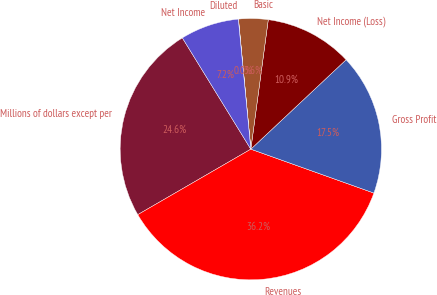Convert chart to OTSL. <chart><loc_0><loc_0><loc_500><loc_500><pie_chart><fcel>Millions of dollars except per<fcel>Revenues<fcel>Gross Profit<fcel>Net Income (Loss)<fcel>Basic<fcel>Diluted<fcel>Net Income<nl><fcel>24.58%<fcel>36.19%<fcel>17.45%<fcel>10.87%<fcel>3.64%<fcel>0.02%<fcel>7.25%<nl></chart> 